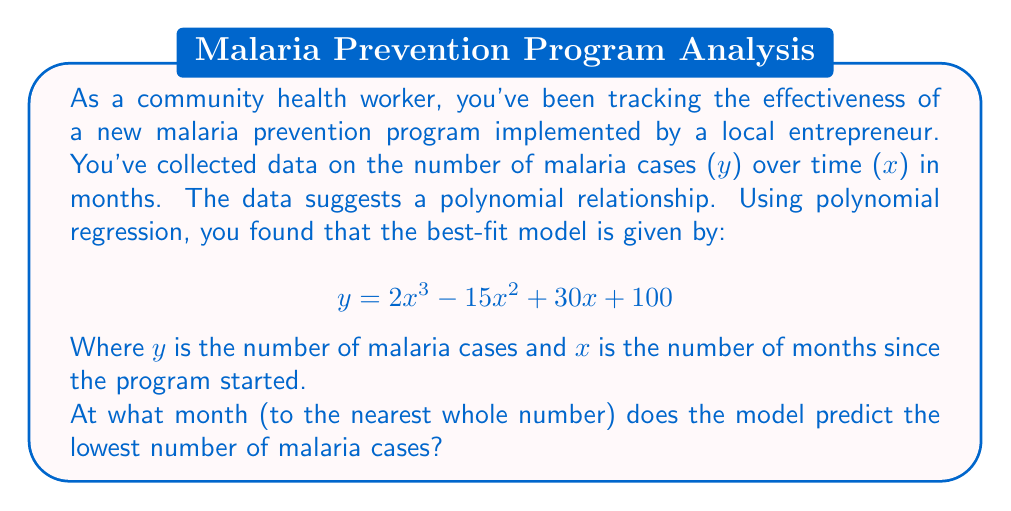Give your solution to this math problem. To find the month with the lowest number of malaria cases, we need to follow these steps:

1) First, we need to find the derivative of the polynomial function:
   $$ \frac{dy}{dx} = 6x^2 - 30x + 30 $$

2) To find the minimum point, we set the derivative equal to zero:
   $$ 6x^2 - 30x + 30 = 0 $$

3) This is a quadratic equation. We can solve it using the quadratic formula:
   $$ x = \frac{-b \pm \sqrt{b^2 - 4ac}}{2a} $$
   Where $a=6$, $b=-30$, and $c=30$

4) Plugging in these values:
   $$ x = \frac{30 \pm \sqrt{900 - 720}}{12} = \frac{30 \pm \sqrt{180}}{12} $$

5) Simplifying:
   $$ x = \frac{30 \pm 6\sqrt{5}}{12} = \frac{15 \pm 3\sqrt{5}}{6} $$

6) This gives us two critical points:
   $$ x_1 = \frac{15 + 3\sqrt{5}}{6} \approx 3.87 $$
   $$ x_2 = \frac{15 - 3\sqrt{5}}{6} \approx 1.13 $$

7) To determine which point is the minimum, we can check the second derivative:
   $$ \frac{d^2y}{dx^2} = 12x - 30 $$

8) At $x = 3.87$, the second derivative is positive, indicating this is the minimum point.

9) Rounding to the nearest whole number:
   $$ 3.87 \approx 4 $$

Therefore, the model predicts the lowest number of malaria cases at approximately 4 months after the program started.
Answer: 4 months 